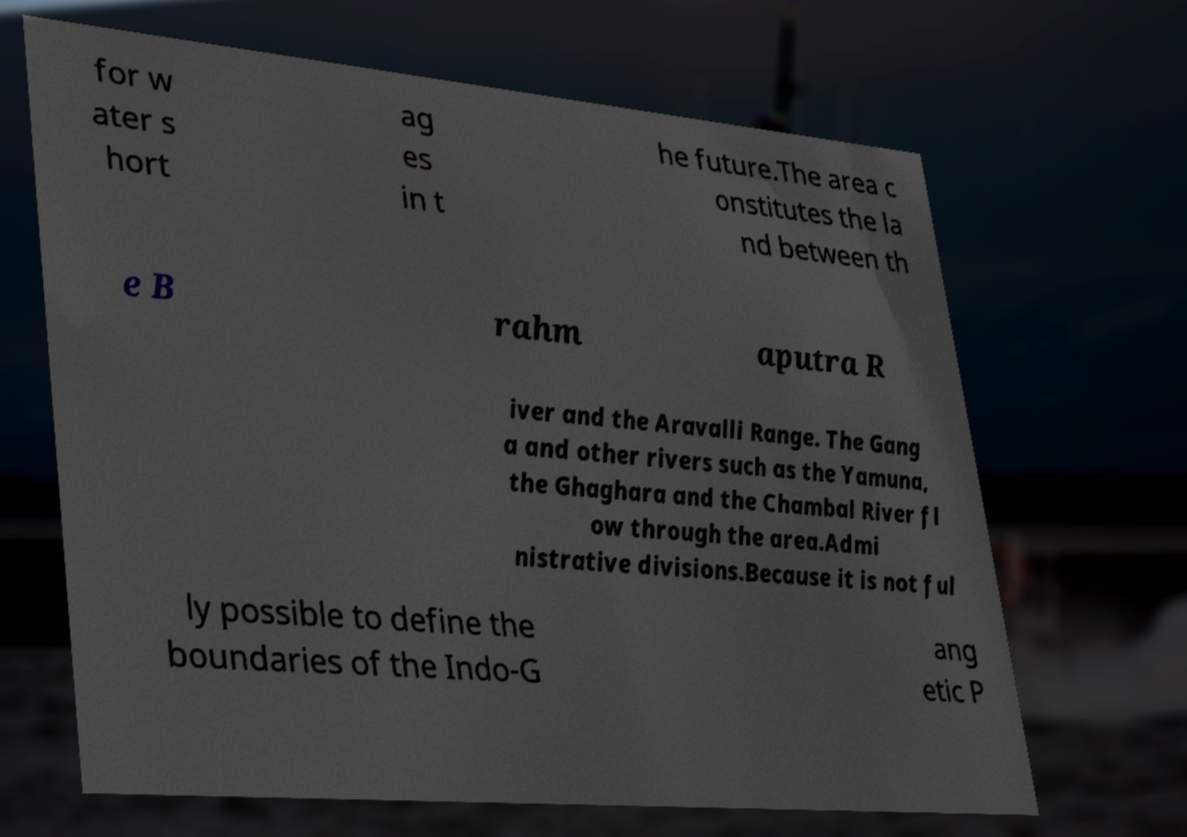Can you read and provide the text displayed in the image?This photo seems to have some interesting text. Can you extract and type it out for me? for w ater s hort ag es in t he future.The area c onstitutes the la nd between th e B rahm aputra R iver and the Aravalli Range. The Gang a and other rivers such as the Yamuna, the Ghaghara and the Chambal River fl ow through the area.Admi nistrative divisions.Because it is not ful ly possible to define the boundaries of the Indo-G ang etic P 